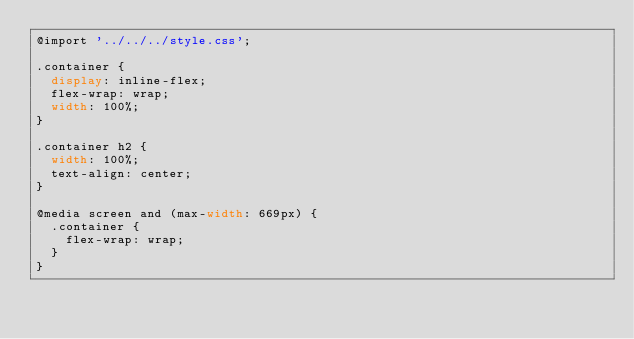<code> <loc_0><loc_0><loc_500><loc_500><_CSS_>@import '../../../style.css';

.container {
  display: inline-flex;
  flex-wrap: wrap;
  width: 100%;
}

.container h2 {
  width: 100%;
  text-align: center;
}

@media screen and (max-width: 669px) {
  .container {
    flex-wrap: wrap;
  }
}
</code> 